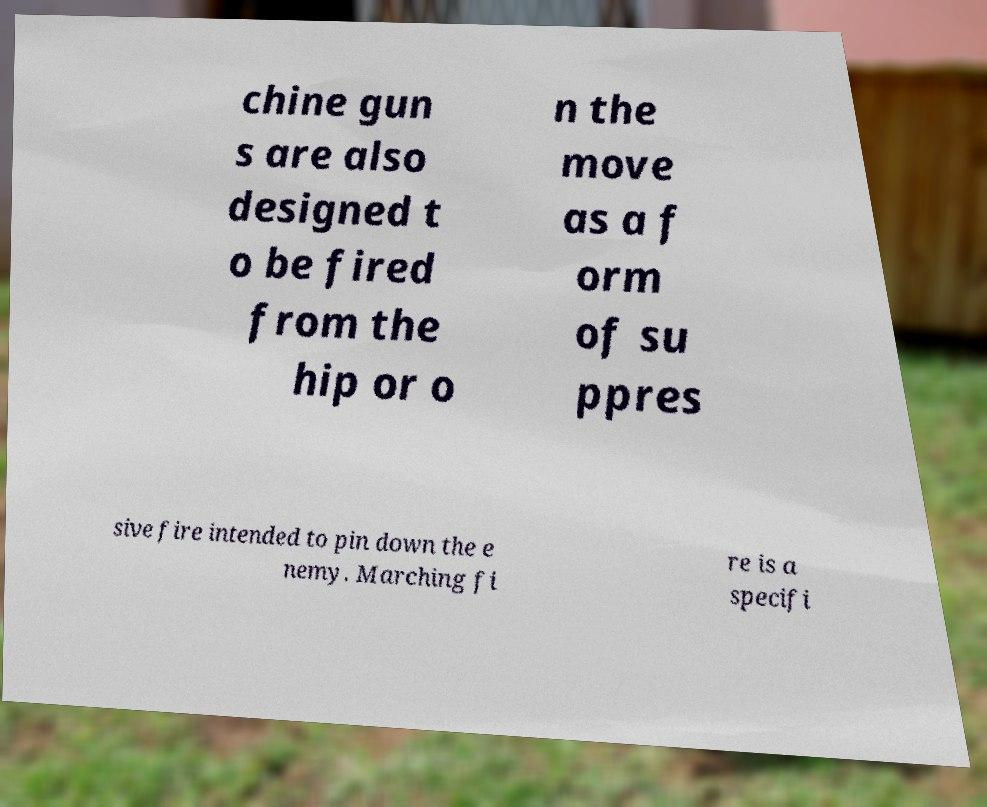I need the written content from this picture converted into text. Can you do that? chine gun s are also designed t o be fired from the hip or o n the move as a f orm of su ppres sive fire intended to pin down the e nemy. Marching fi re is a specifi 